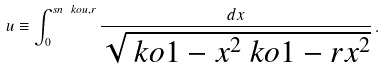Convert formula to latex. <formula><loc_0><loc_0><loc_500><loc_500>u \equiv \int _ { 0 } ^ { s n \ k o { u , r } } \frac { d x } { \sqrt { \ k o { 1 - x ^ { 2 } } \ k o { 1 - r x ^ { 2 } } } } \, .</formula> 